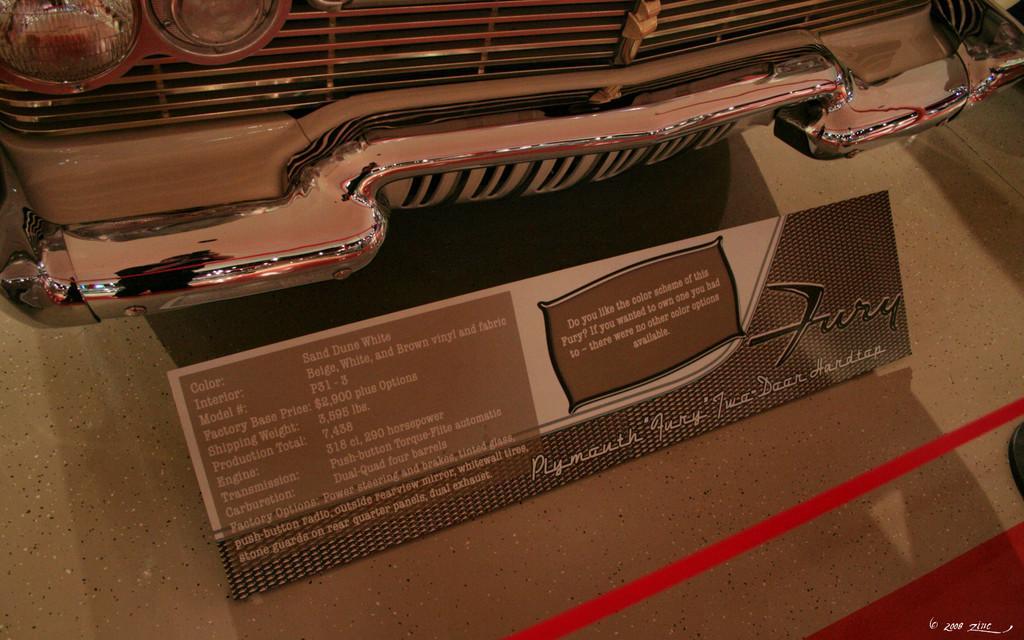Describe this image in one or two sentences. In this image, we can see a car and there is a specification board of the car on the ground, we can see a ribbon. 